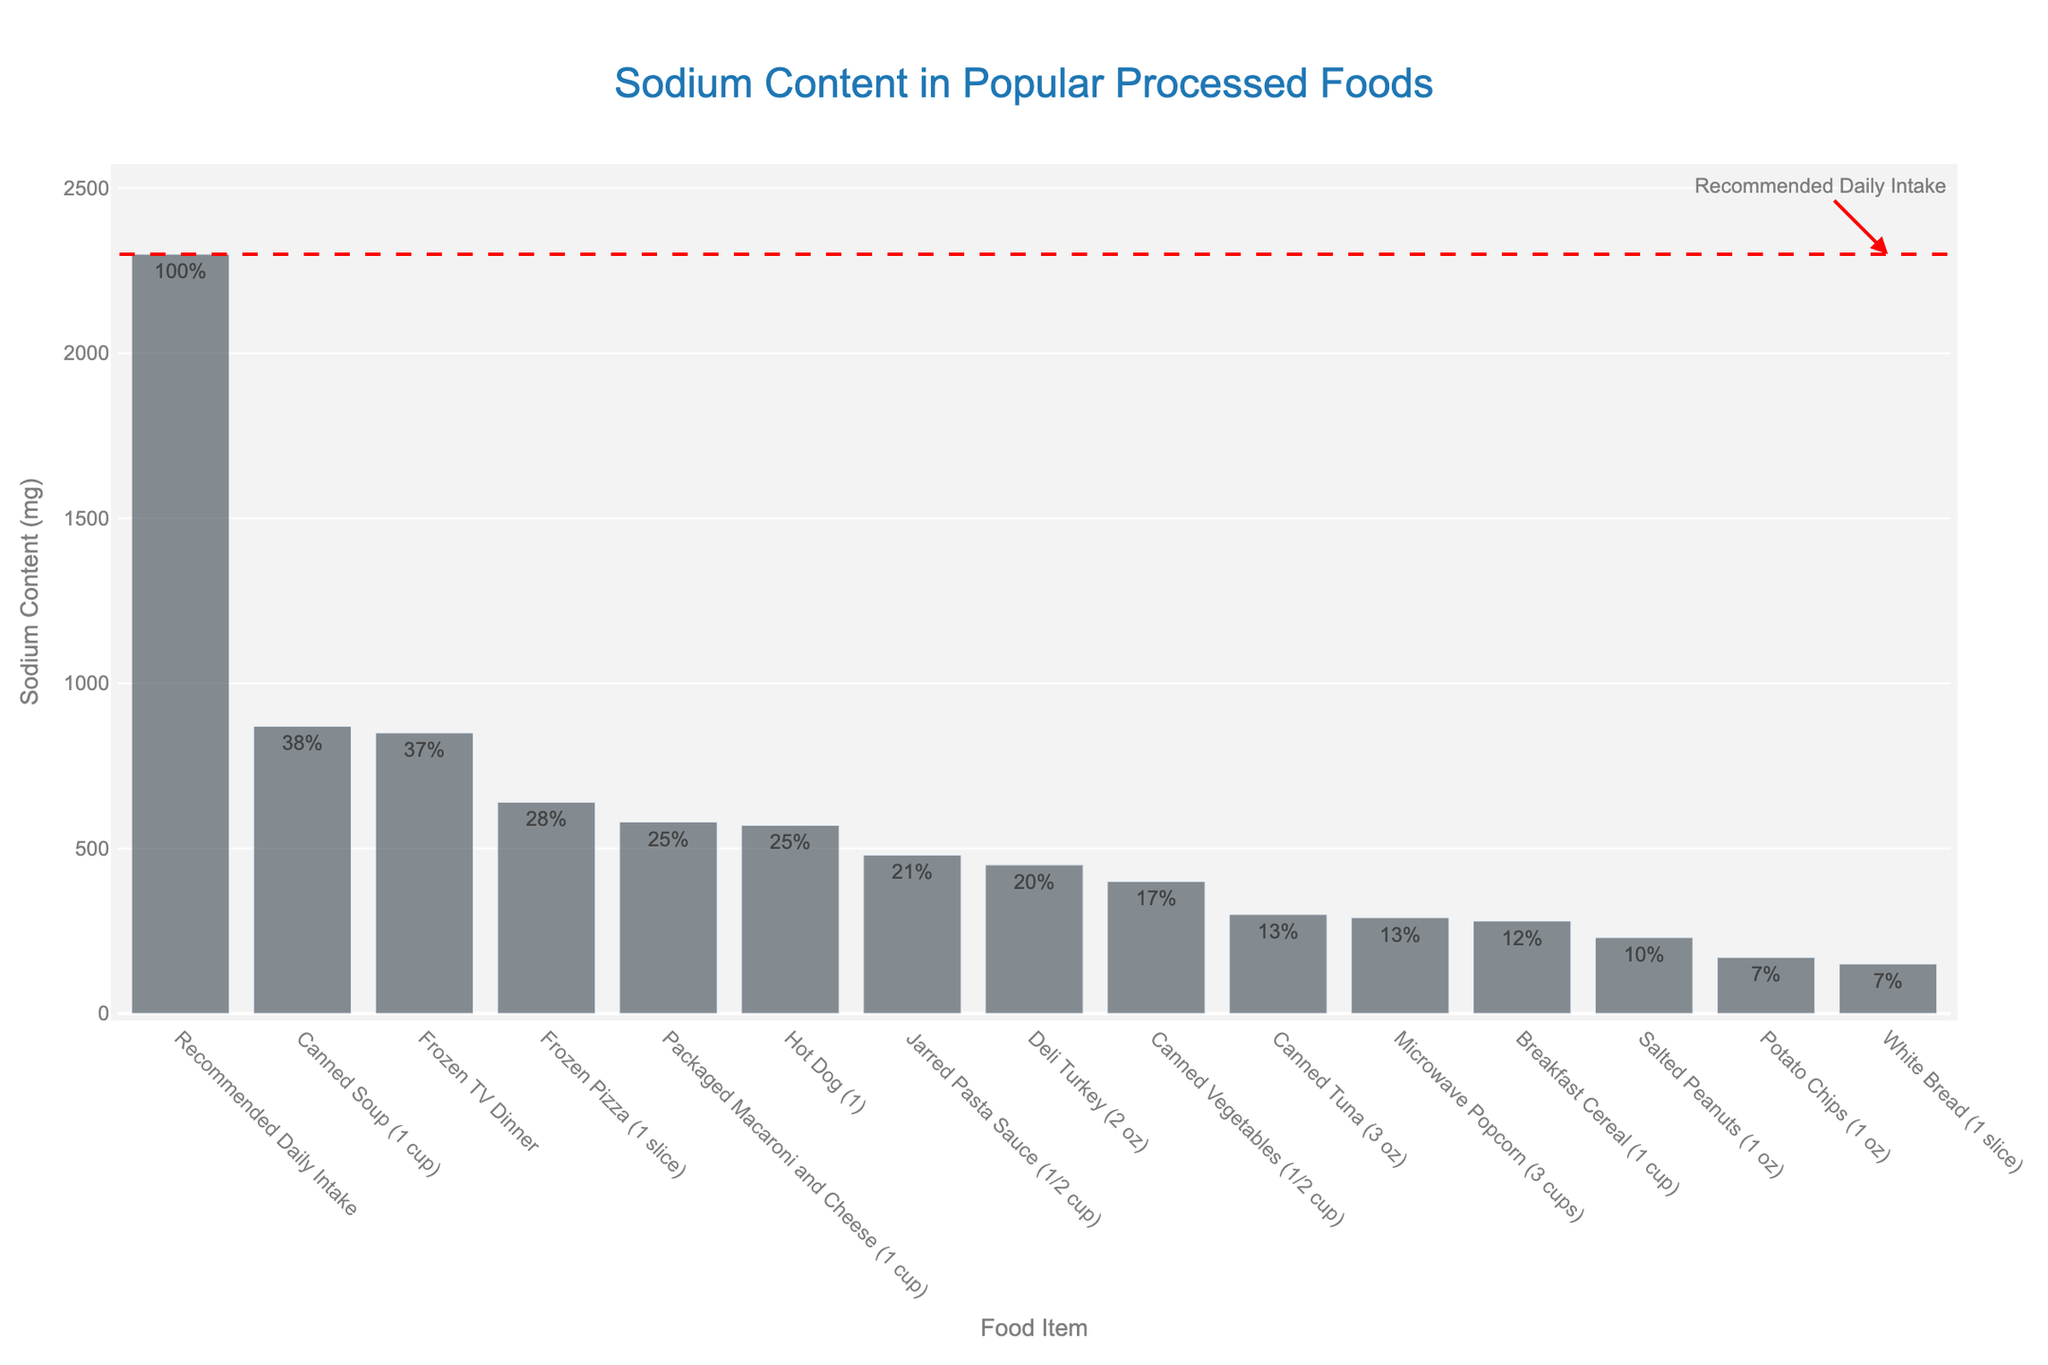What food item has the highest sodium content? The tallest bar in the chart represents the food item with the highest sodium content. Canned Soup (1 cup) has the highest sodium content of 870 mg.
Answer: Canned Soup (1 cup) How does the sodium content of Frozen TV Dinner compare to Recommended Daily Intake? The bar for Frozen TV Dinner is close to the recommended daily intake line but does not touch it. Frozen TV Dinner contains 850 mg of sodium, which is less than the recommended daily intake of 2300 mg.
Answer: Less Which food item covers the highest percent of the recommended daily value of sodium? By examining the labels on the bars, the food item with the highest percentage is Canned Soup (1 cup) at 38%.
Answer: Canned Soup (1 cup) What is the difference in sodium content between Deli Turkey (2 oz) and Canned Vegetables (1/2 cup)? Subtract the sodium content of Canned Vegetables (400 mg) from Deli Turkey (450 mg). 450 mg - 400 mg = 50 mg
Answer: 50 mg How many food items contain sodium that makes up at least 25% of the recommended daily value? By looking at the labels, three food items: Frozen Pizza (1 slice), Packaged Macaroni and Cheese (1 cup), and Hot Dog (1).
Answer: 3 What is the combined sodium content of Potato Chips (1 oz) and Salted Peanuts (1 oz)? Add the sodium content of Potato Chips (170 mg) and Salted Peanuts (230 mg). 170 mg + 230 mg = 400 mg
Answer: 400 mg Which food item has a sodium percentage closest to 20% of the recommended daily intake? By looking at the labels for percentage, Deli Turkey (2 oz) has 20% of the recommended daily value.
Answer: Deli Turkey (2 oz) Is the sodium content of Jarred Pasta Sauce (1/2 cup) greater than that of Canned Tuna (3 oz)? Compare the bars visually: Jarred Pasta Sauce (480 mg) is higher than Canned Tuna (300 mg).
Answer: Yes Which food item has the second-lowest sodium content? The second shortest bar in the chart represents White Bread (1 slice) with 150 mg of sodium.
Answer: White Bread (1 slice) What is the average sodium content of Canned Soup (1 cup), Frozen Pizza (1 slice), and Frozen TV Dinner? Add the sodium contents and divide by the number of items: (870 mg + 640 mg + 850 mg) / 3 = 2360 mg / 3 ≈ 787 mg
Answer: 787 mg 